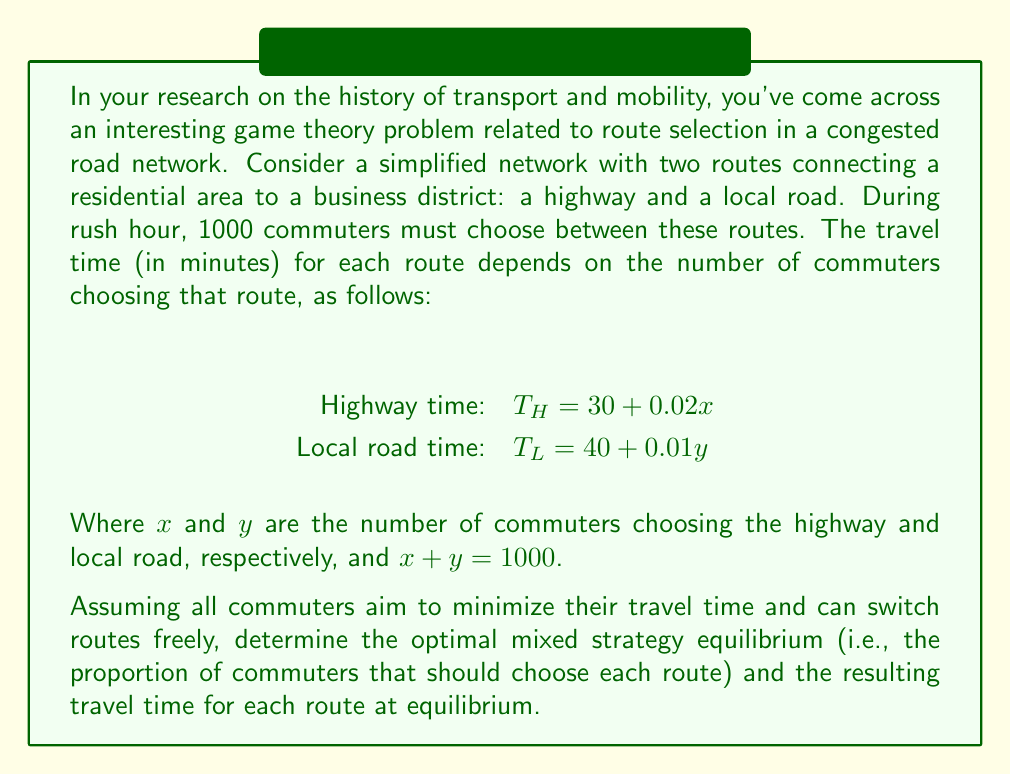Can you solve this math problem? To solve this problem, we'll use the concept of Nash equilibrium in mixed strategies. At equilibrium, the travel times on both routes should be equal; otherwise, commuters would have an incentive to switch routes.

Let's follow these steps:

1) Let $p$ be the proportion of commuters choosing the highway. Then, $(1-p)$ is the proportion choosing the local road.

2) The number of commuters on each route can be expressed as:
   $x = 1000p$ (highway)
   $y = 1000(1-p)$ (local road)

3) Substitute these into the travel time equations:
   $T_H = 30 + 0.02(1000p) = 30 + 20p$
   $T_L = 40 + 0.01(1000(1-p)) = 40 + 10 - 10p$

4) At equilibrium, these travel times should be equal:
   $T_H = T_L$
   $30 + 20p = 40 + 10 - 10p$

5) Solve this equation for $p$:
   $30 + 20p = 50 - 10p$
   $30p = 20$
   $p = \frac{2}{3}$

6) This means that at equilibrium, $\frac{2}{3}$ of the commuters should choose the highway, and $\frac{1}{3}$ should choose the local road.

7) To find the travel time at equilibrium, substitute $p = \frac{2}{3}$ into either travel time equation:
   $T_H = 30 + 20(\frac{2}{3}) = 30 + \frac{40}{3} = \frac{130}{3} \approx 43.33$ minutes
   
   (We could also use $T_L$ and get the same result, confirming our equilibrium.)
Answer: The optimal mixed strategy equilibrium is for $\frac{2}{3}$ of the commuters to choose the highway and $\frac{1}{3}$ to choose the local road. At this equilibrium, the travel time on both routes will be $\frac{130}{3} \approx 43.33$ minutes. 